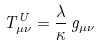<formula> <loc_0><loc_0><loc_500><loc_500>T ^ { U } _ { \mu \nu } = \frac { \lambda } { \kappa } \, g _ { \mu \nu }</formula> 